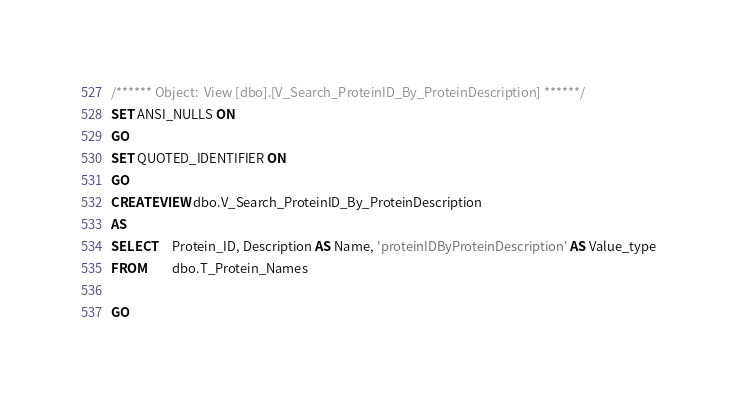<code> <loc_0><loc_0><loc_500><loc_500><_SQL_>/****** Object:  View [dbo].[V_Search_ProteinID_By_ProteinDescription] ******/
SET ANSI_NULLS ON
GO
SET QUOTED_IDENTIFIER ON
GO
CREATE VIEW dbo.V_Search_ProteinID_By_ProteinDescription
AS
SELECT     Protein_ID, Description AS Name, 'proteinIDByProteinDescription' AS Value_type
FROM         dbo.T_Protein_Names

GO
</code> 